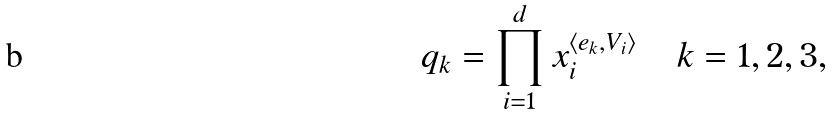<formula> <loc_0><loc_0><loc_500><loc_500>q _ { k } = \prod _ { i = 1 } ^ { d } x _ { i } ^ { \langle e _ { k } , V _ { i } \rangle } \, \quad k = 1 , 2 , 3 ,</formula> 